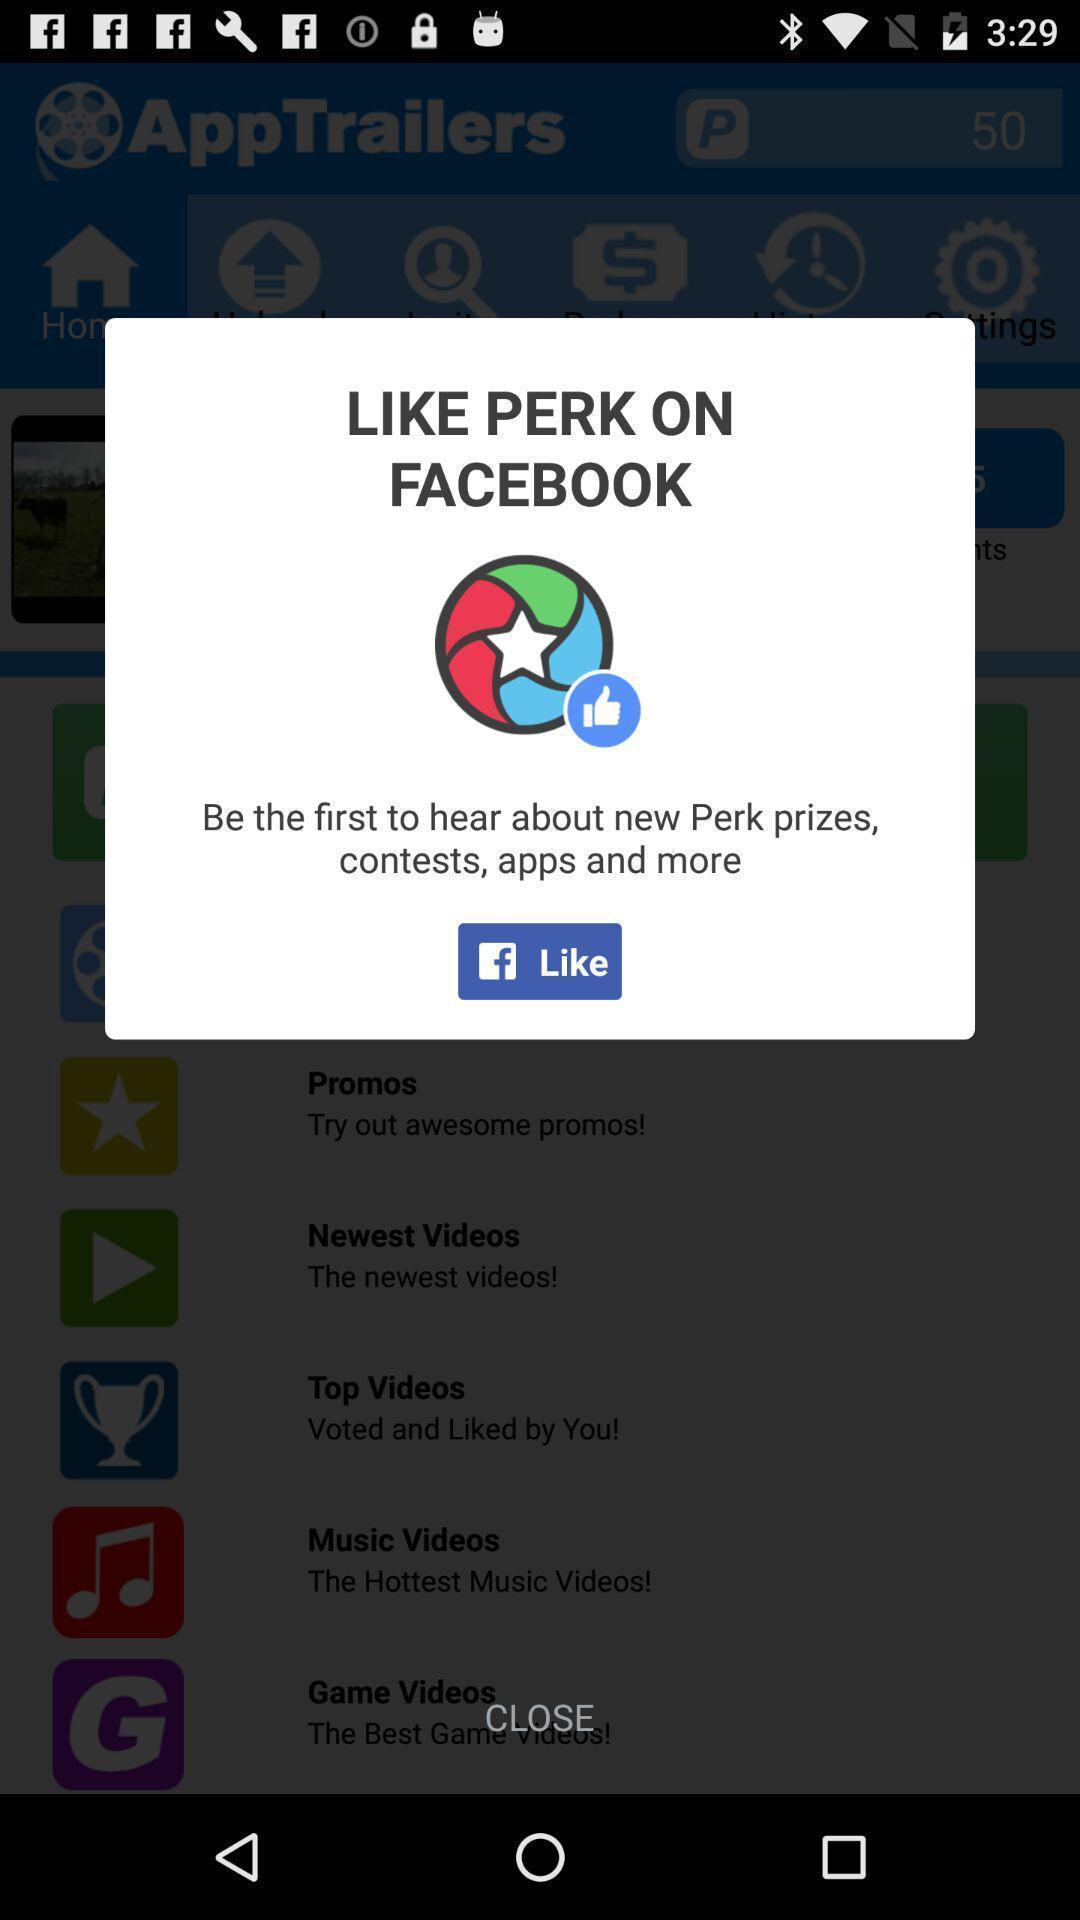Give me a summary of this screen capture. Popup displaying information about a social application. 